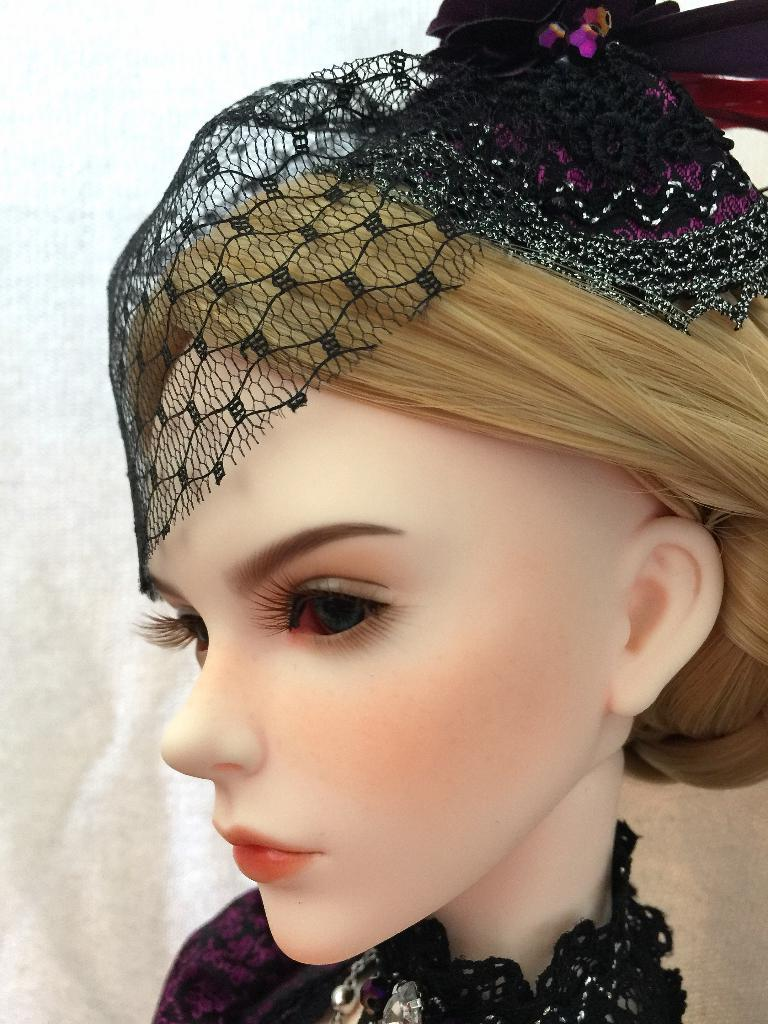What is the main subject of the image? There is a doll in the image. What is the doll wearing? The doll is wearing a black dress. How many pickles are on the doll's head in the image? There are no pickles present in the image, as it features a doll wearing a black dress. 